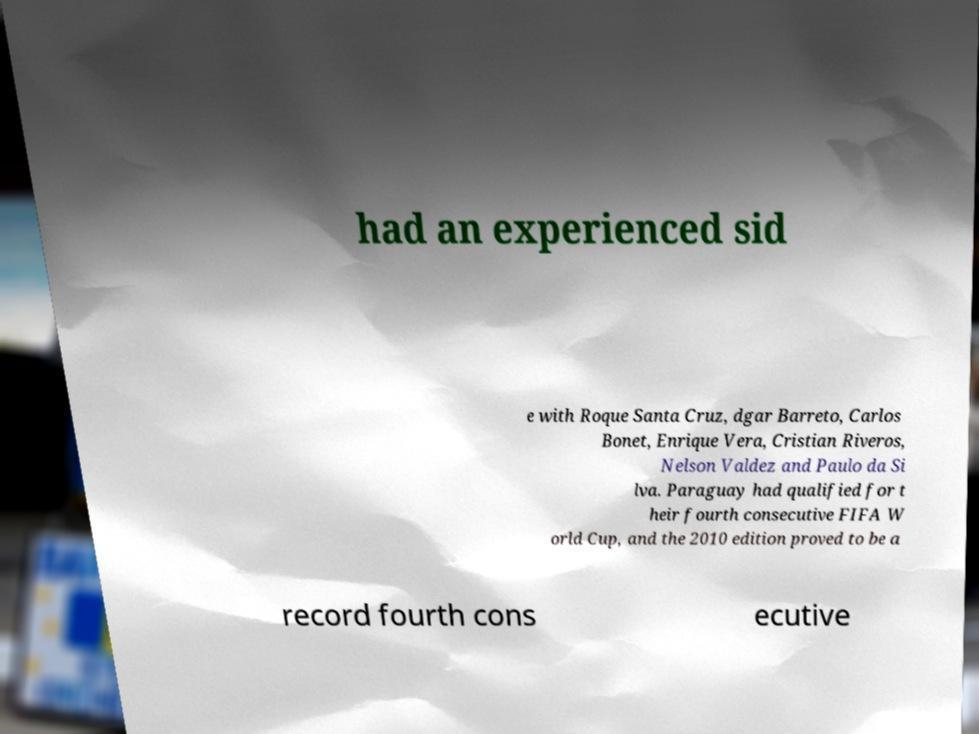Please read and relay the text visible in this image. What does it say? had an experienced sid e with Roque Santa Cruz, dgar Barreto, Carlos Bonet, Enrique Vera, Cristian Riveros, Nelson Valdez and Paulo da Si lva. Paraguay had qualified for t heir fourth consecutive FIFA W orld Cup, and the 2010 edition proved to be a record fourth cons ecutive 